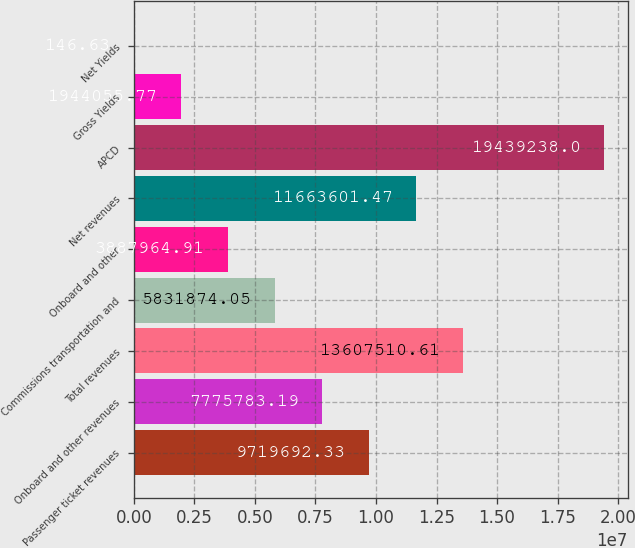Convert chart. <chart><loc_0><loc_0><loc_500><loc_500><bar_chart><fcel>Passenger ticket revenues<fcel>Onboard and other revenues<fcel>Total revenues<fcel>Commissions transportation and<fcel>Onboard and other<fcel>Net revenues<fcel>APCD<fcel>Gross Yields<fcel>Net Yields<nl><fcel>9.71969e+06<fcel>7.77578e+06<fcel>1.36075e+07<fcel>5.83187e+06<fcel>3.88796e+06<fcel>1.16636e+07<fcel>1.94392e+07<fcel>1.94406e+06<fcel>146.63<nl></chart> 